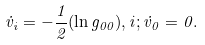<formula> <loc_0><loc_0><loc_500><loc_500>\dot { v } _ { i } = - \frac { 1 } { 2 } ( \ln g _ { 0 0 } ) , i ; \dot { v } _ { 0 } = 0 .</formula> 